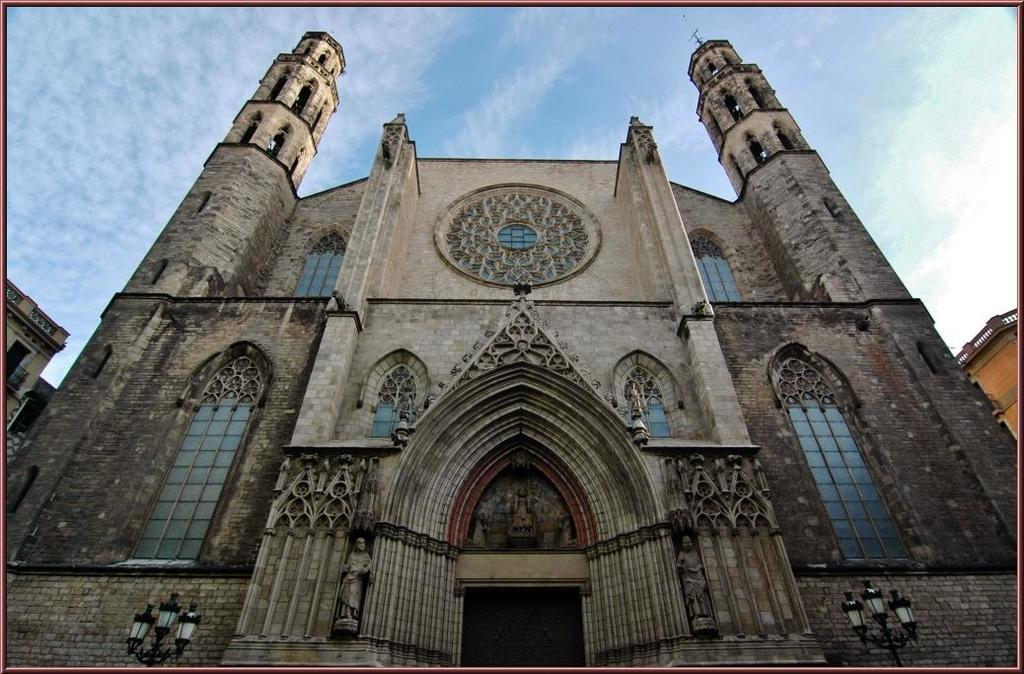What type of structures can be seen in the image? There are buildings in the image. What can be seen illuminating the scene in the image? There are lights visible in the image. What is the condition of the sky in the background of the image? The sky is clear in the background of the image. What color is the tail of the silver object in the image? There is no silver object with a tail present in the image. 